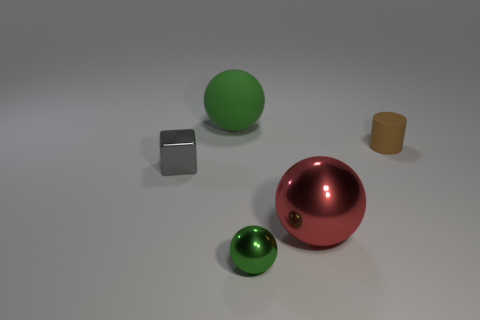Subtract all big spheres. How many spheres are left? 1 Add 4 tiny cyan cylinders. How many objects exist? 9 Subtract all red balls. How many balls are left? 2 Subtract all spheres. How many objects are left? 2 Subtract 1 cylinders. How many cylinders are left? 0 Subtract all purple blocks. Subtract all red cylinders. How many blocks are left? 1 Subtract all yellow blocks. How many cyan cylinders are left? 0 Subtract all tiny brown rubber objects. Subtract all red matte cylinders. How many objects are left? 4 Add 2 small brown cylinders. How many small brown cylinders are left? 3 Add 1 tiny green shiny things. How many tiny green shiny things exist? 2 